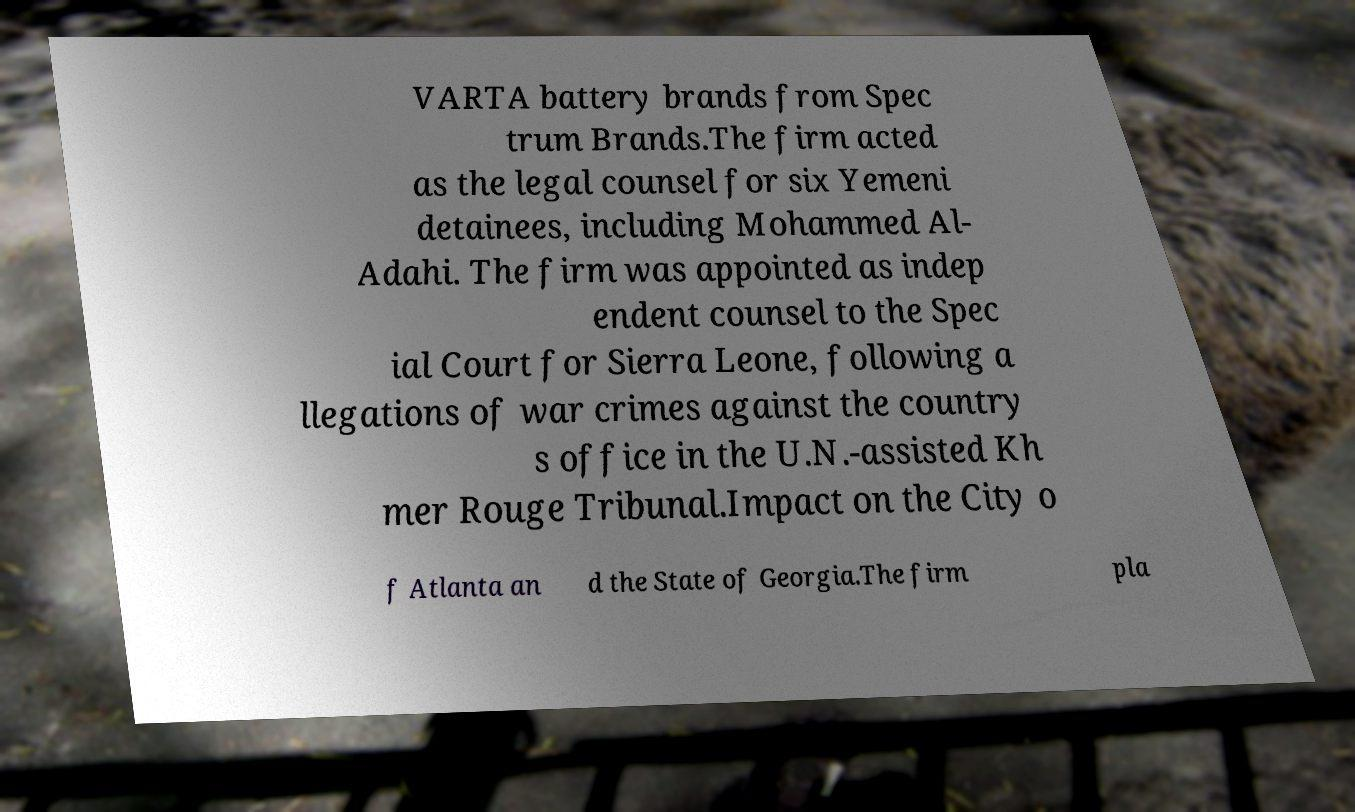For documentation purposes, I need the text within this image transcribed. Could you provide that? VARTA battery brands from Spec trum Brands.The firm acted as the legal counsel for six Yemeni detainees, including Mohammed Al- Adahi. The firm was appointed as indep endent counsel to the Spec ial Court for Sierra Leone, following a llegations of war crimes against the country s office in the U.N.-assisted Kh mer Rouge Tribunal.Impact on the City o f Atlanta an d the State of Georgia.The firm pla 